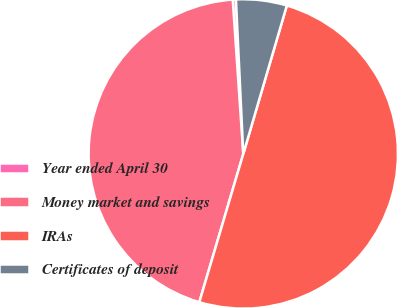Convert chart to OTSL. <chart><loc_0><loc_0><loc_500><loc_500><pie_chart><fcel>Year ended April 30<fcel>Money market and savings<fcel>IRAs<fcel>Certificates of deposit<nl><fcel>0.33%<fcel>44.33%<fcel>50.05%<fcel>5.3%<nl></chart> 